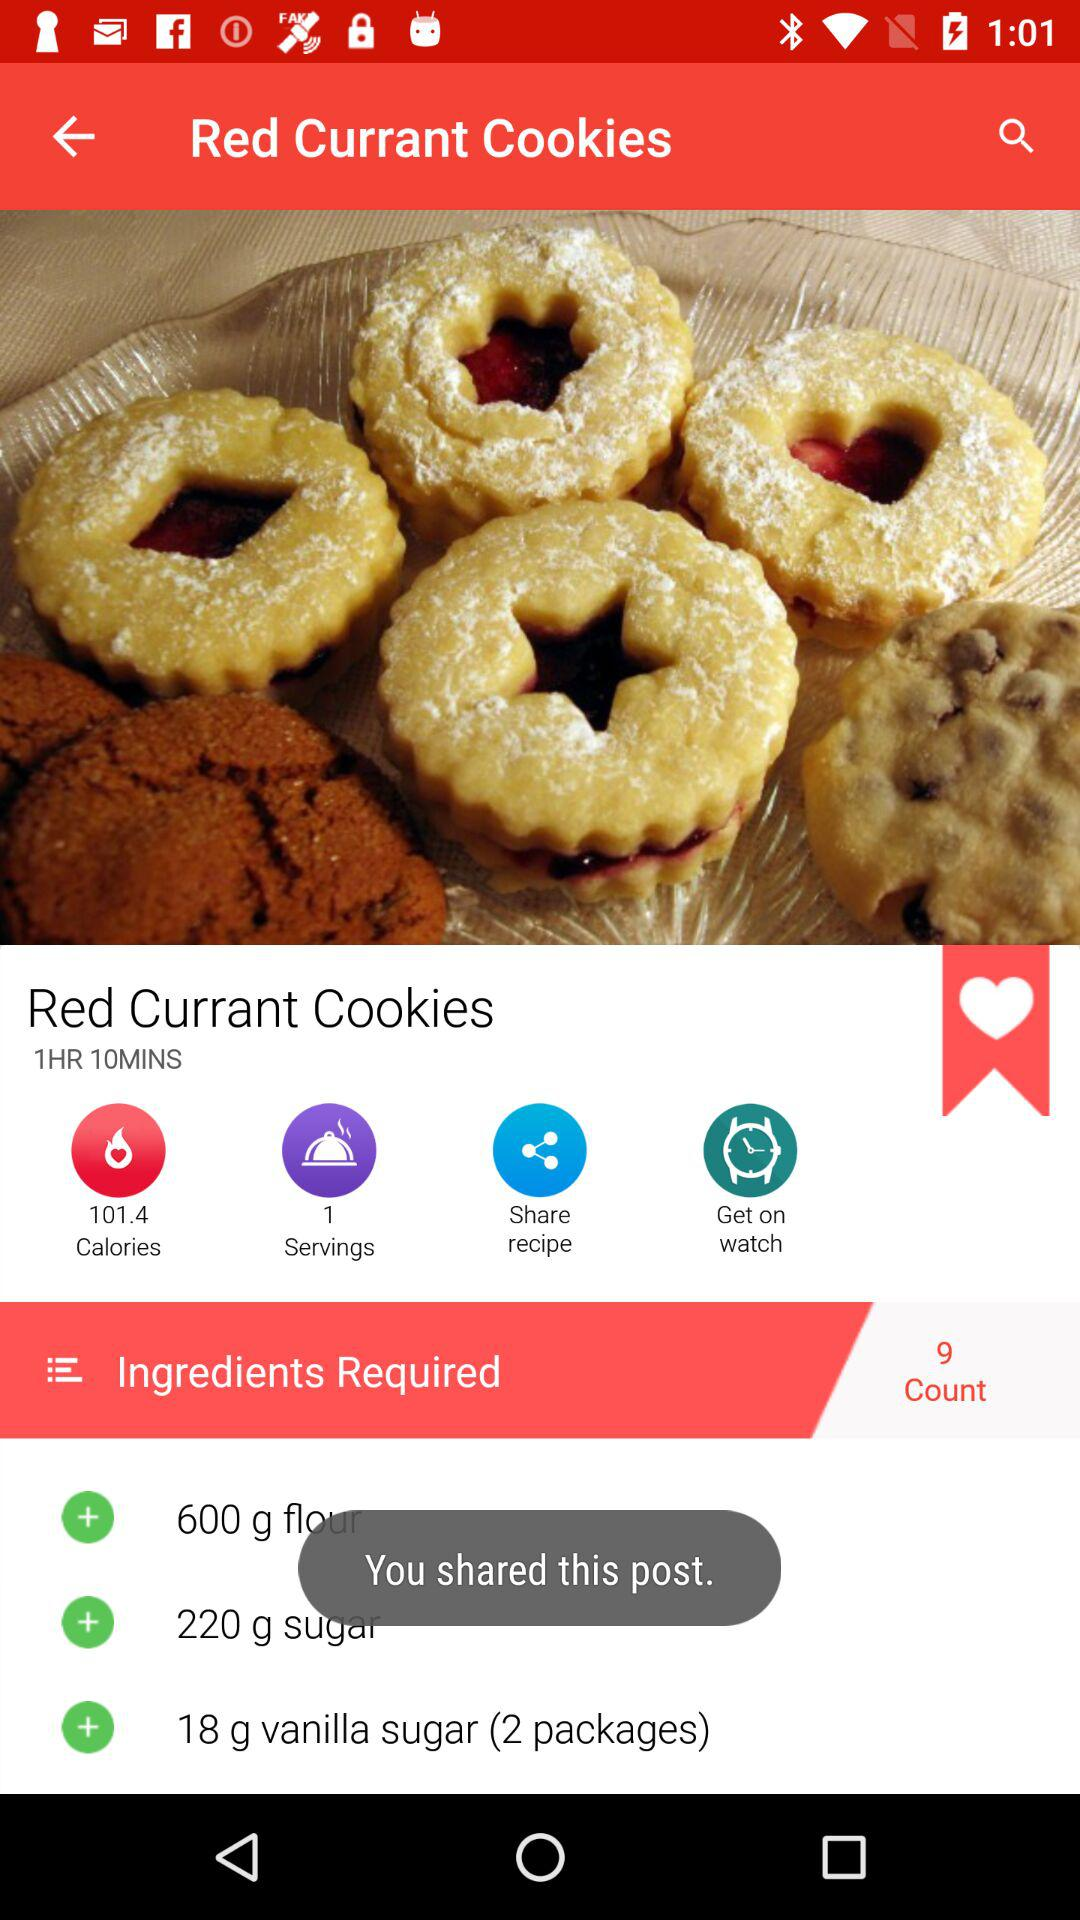How many vanilla packages are used? There are 2 vanilla packages that are used. 